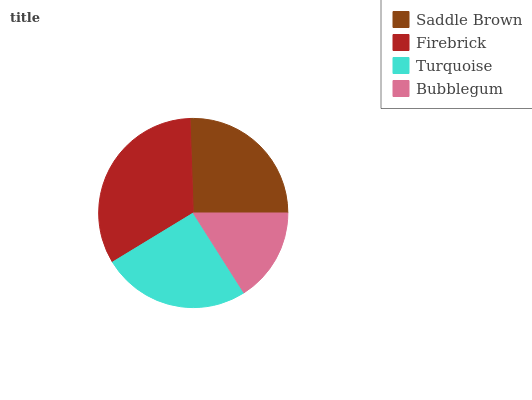Is Bubblegum the minimum?
Answer yes or no. Yes. Is Firebrick the maximum?
Answer yes or no. Yes. Is Turquoise the minimum?
Answer yes or no. No. Is Turquoise the maximum?
Answer yes or no. No. Is Firebrick greater than Turquoise?
Answer yes or no. Yes. Is Turquoise less than Firebrick?
Answer yes or no. Yes. Is Turquoise greater than Firebrick?
Answer yes or no. No. Is Firebrick less than Turquoise?
Answer yes or no. No. Is Saddle Brown the high median?
Answer yes or no. Yes. Is Turquoise the low median?
Answer yes or no. Yes. Is Firebrick the high median?
Answer yes or no. No. Is Saddle Brown the low median?
Answer yes or no. No. 